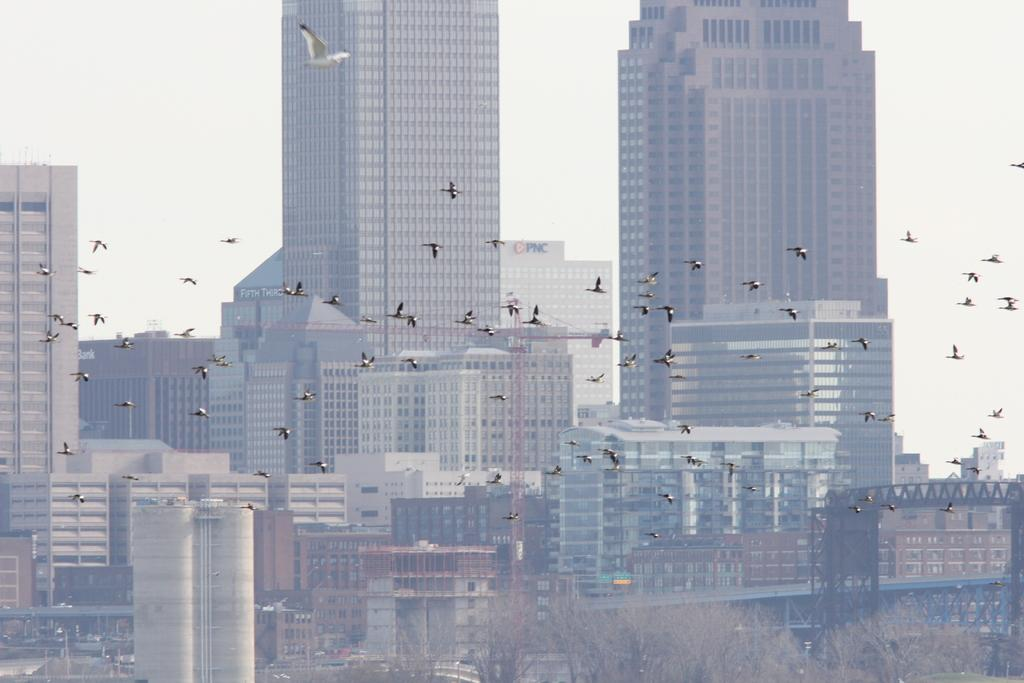What is happening in the sky in the image? There are birds flying in the image. What type of structures can be seen in the image? There are buildings visible in the image. What type of vegetation is at the bottom of the image? There are trees at the bottom of the image. What is visible behind the buildings in the image? The sky is visible behind the buildings. What type of minister is standing next to the trees in the image? There is no minister present in the image; it features birds flying, buildings, trees, and the sky. How does the wind affect the wheel in the image? There is no wheel present in the image, so it is not possible to determine how the wind might affect it. 